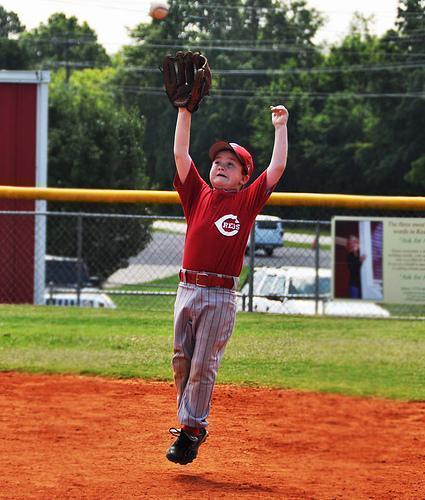What is the outcome if the ball went over the fence?
From the following set of four choices, select the accurate answer to respond to the question.
Options: Hit, walk, out, home run. Home run. 